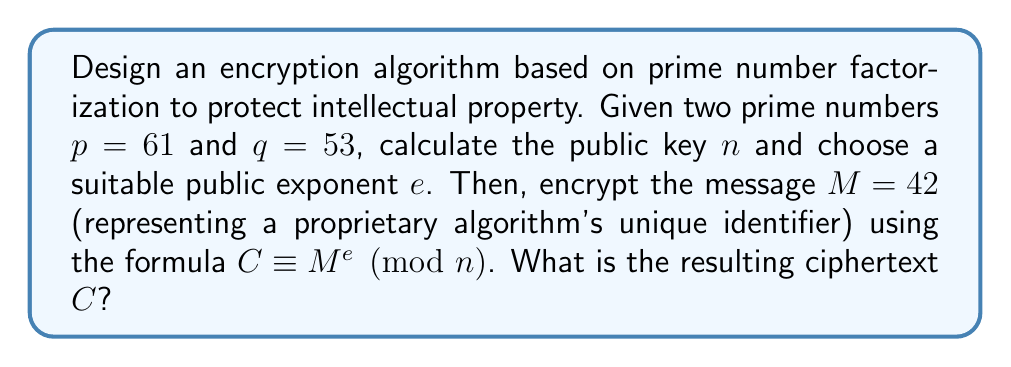Solve this math problem. To design an encryption algorithm based on prime number factorization, we'll use the RSA (Rivest-Shamir-Adleman) cryptosystem, which is widely used for secure data transmission and digital signatures. This method is particularly suitable for protecting intellectual property due to its robust security features. Let's follow these steps:

1. Calculate the public key $n$:
   $n = p \times q = 61 \times 53 = 3233$

2. Calculate Euler's totient function $\phi(n)$:
   $\phi(n) = (p-1)(q-1) = 60 \times 52 = 3120$

3. Choose a suitable public exponent $e$:
   $e$ must be coprime to $\phi(n)$ and $1 < e < \phi(n)$
   Let's choose $e = 17$ (a common choice that satisfies these conditions)

4. Encrypt the message $M = 42$ using the formula:
   $C \equiv M^e \pmod{n}$

   $C \equiv 42^{17} \pmod{3233}$

To calculate this efficiently, we can use the square-and-multiply algorithm:

$42^1 \equiv 42 \pmod{3233}$
$42^2 \equiv 1764 \pmod{3233}$
$42^4 \equiv 1764^2 \equiv 3107 \pmod{3233}$
$42^8 \equiv 3107^2 \equiv 2318 \pmod{3233}$
$42^{16} \equiv 2318^2 \equiv 2030 \pmod{3233}$

Now, $17 = 16 + 1$, so:
$42^{17} \equiv 42^{16} \times 42^1 \pmod{3233}$
$\equiv 2030 \times 42 \pmod{3233}$
$\equiv 2982 \pmod{3233}$

Therefore, the ciphertext $C = 2982$.
Answer: $C = 2982$ 